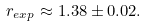Convert formula to latex. <formula><loc_0><loc_0><loc_500><loc_500>r _ { e x p } \approx 1 . 3 8 \pm 0 . 0 2 .</formula> 